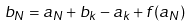Convert formula to latex. <formula><loc_0><loc_0><loc_500><loc_500>b _ { N } = a _ { N } + b _ { k } - a _ { k } + f ( a _ { N } )</formula> 